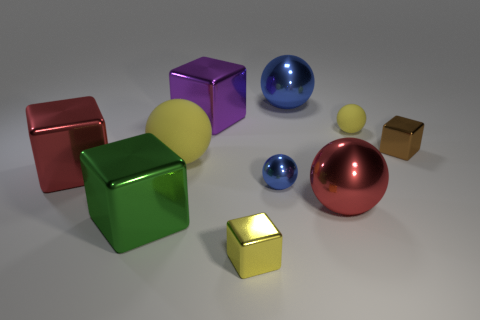How many big objects are either red spheres or brown metallic cubes?
Give a very brief answer. 1. Is there a large green cube that is behind the small yellow ball that is behind the tiny blue object?
Offer a terse response. No. Are there any big purple matte things?
Your answer should be compact. No. What color is the block to the left of the large cube in front of the big red shiny cube?
Offer a very short reply. Red. There is a large red object that is the same shape as the small matte object; what is it made of?
Your response must be concise. Metal. How many blue metallic things have the same size as the purple metal block?
Ensure brevity in your answer.  1. The yellow sphere that is the same material as the big yellow thing is what size?
Provide a short and direct response. Small. How many big purple things have the same shape as the small matte object?
Keep it short and to the point. 0. How many small shiny cubes are there?
Make the answer very short. 2. There is a yellow matte thing behind the big yellow rubber ball; is its shape the same as the brown object?
Offer a terse response. No. 